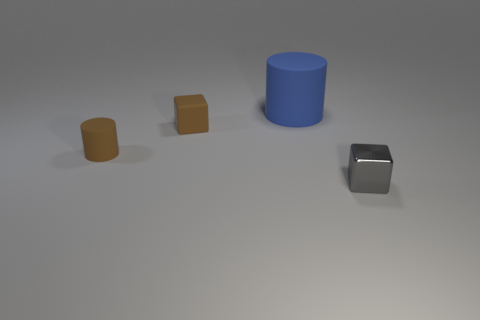Add 3 large rubber cubes. How many objects exist? 7 Add 2 blue matte things. How many blue matte things are left? 3 Add 1 blue cubes. How many blue cubes exist? 1 Subtract 0 green balls. How many objects are left? 4 Subtract all gray blocks. Subtract all small brown cylinders. How many objects are left? 2 